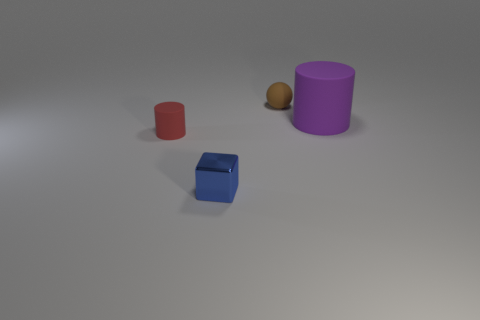Add 1 tiny brown cylinders. How many objects exist? 5 Subtract all spheres. How many objects are left? 3 Add 3 purple objects. How many purple objects are left? 4 Add 1 brown metallic blocks. How many brown metallic blocks exist? 1 Subtract 0 red cubes. How many objects are left? 4 Subtract all brown objects. Subtract all purple things. How many objects are left? 2 